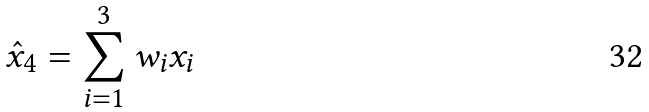<formula> <loc_0><loc_0><loc_500><loc_500>\hat { x } _ { 4 } = \sum _ { i = 1 } ^ { 3 } w _ { i } x _ { i }</formula> 